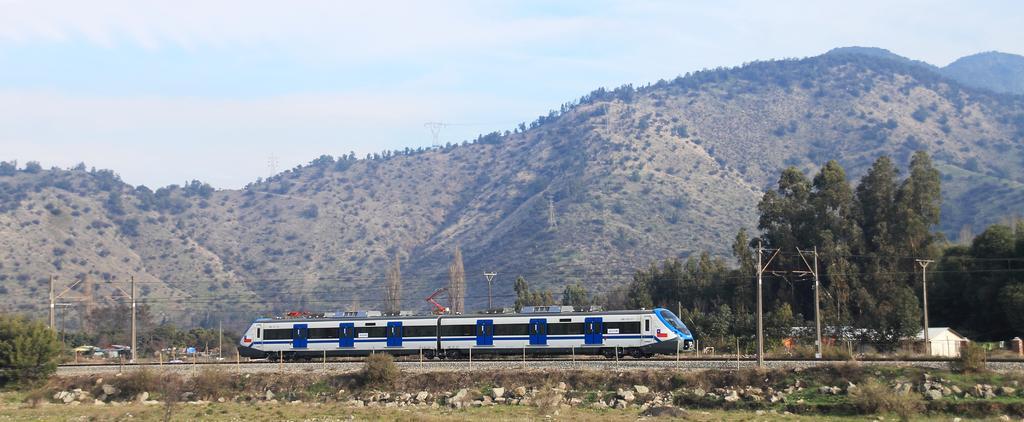In one or two sentences, can you explain what this image depicts? In this image, I can see the trees, rocks, plants, houses, current poles and a train on the railway track. In the background, there are hills and the sky. 